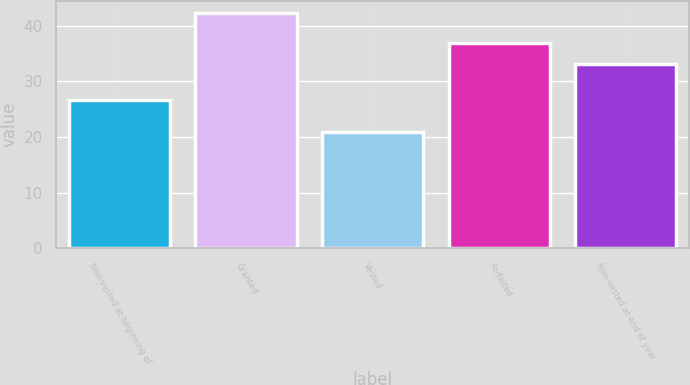Convert chart to OTSL. <chart><loc_0><loc_0><loc_500><loc_500><bar_chart><fcel>Non-vested at beginning of<fcel>Granted<fcel>Vested<fcel>Forfeited<fcel>Non-vested at end of year<nl><fcel>26.59<fcel>42.25<fcel>20.95<fcel>36.9<fcel>33.12<nl></chart> 